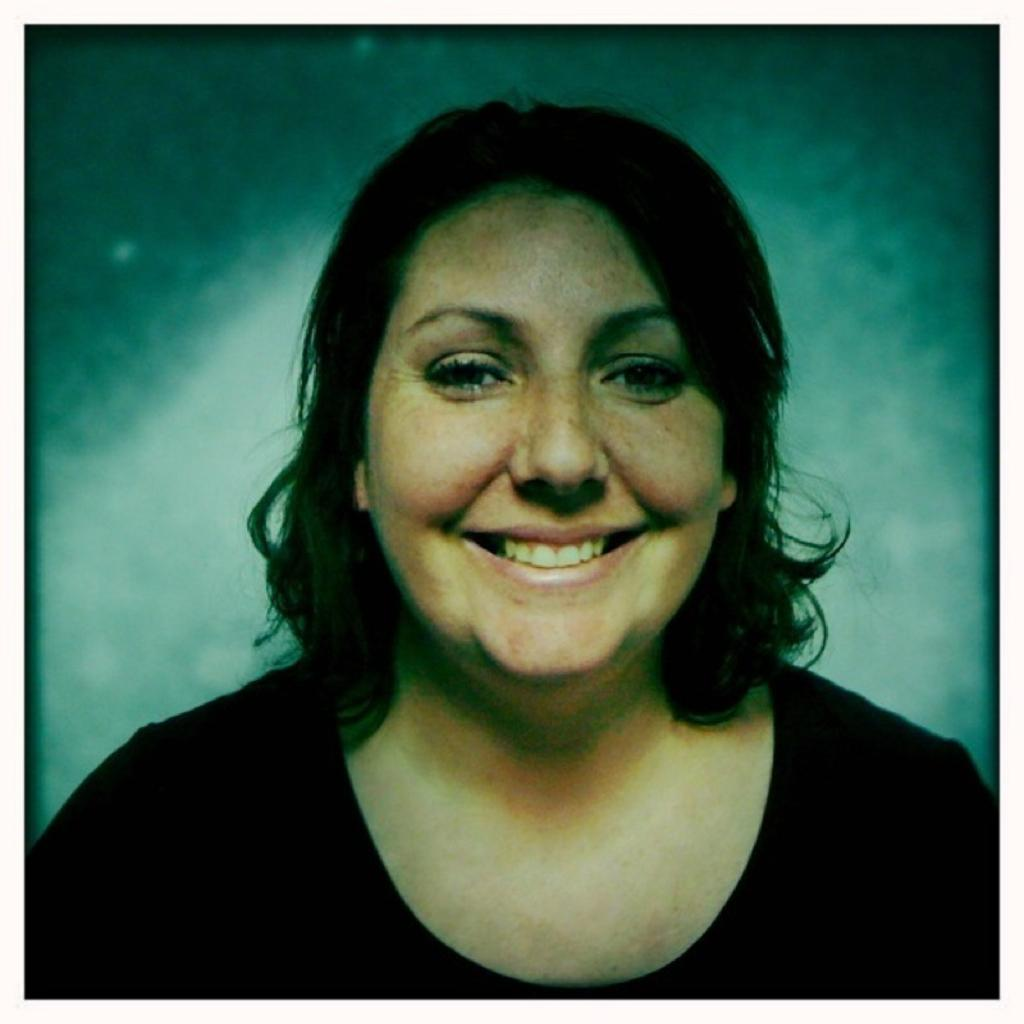What is the main subject of the image? The main subject of the image is a woman. What is the woman doing in the image? The woman is smiling in the image. Can you describe the background of the image? The background of the image is blurred. Can you see any fog in the image? There is no fog visible in the image. Is there a nest present in the image? There is no nest present in the image. What type of pet is the woman holding in the image? There is no pet visible in the image. 